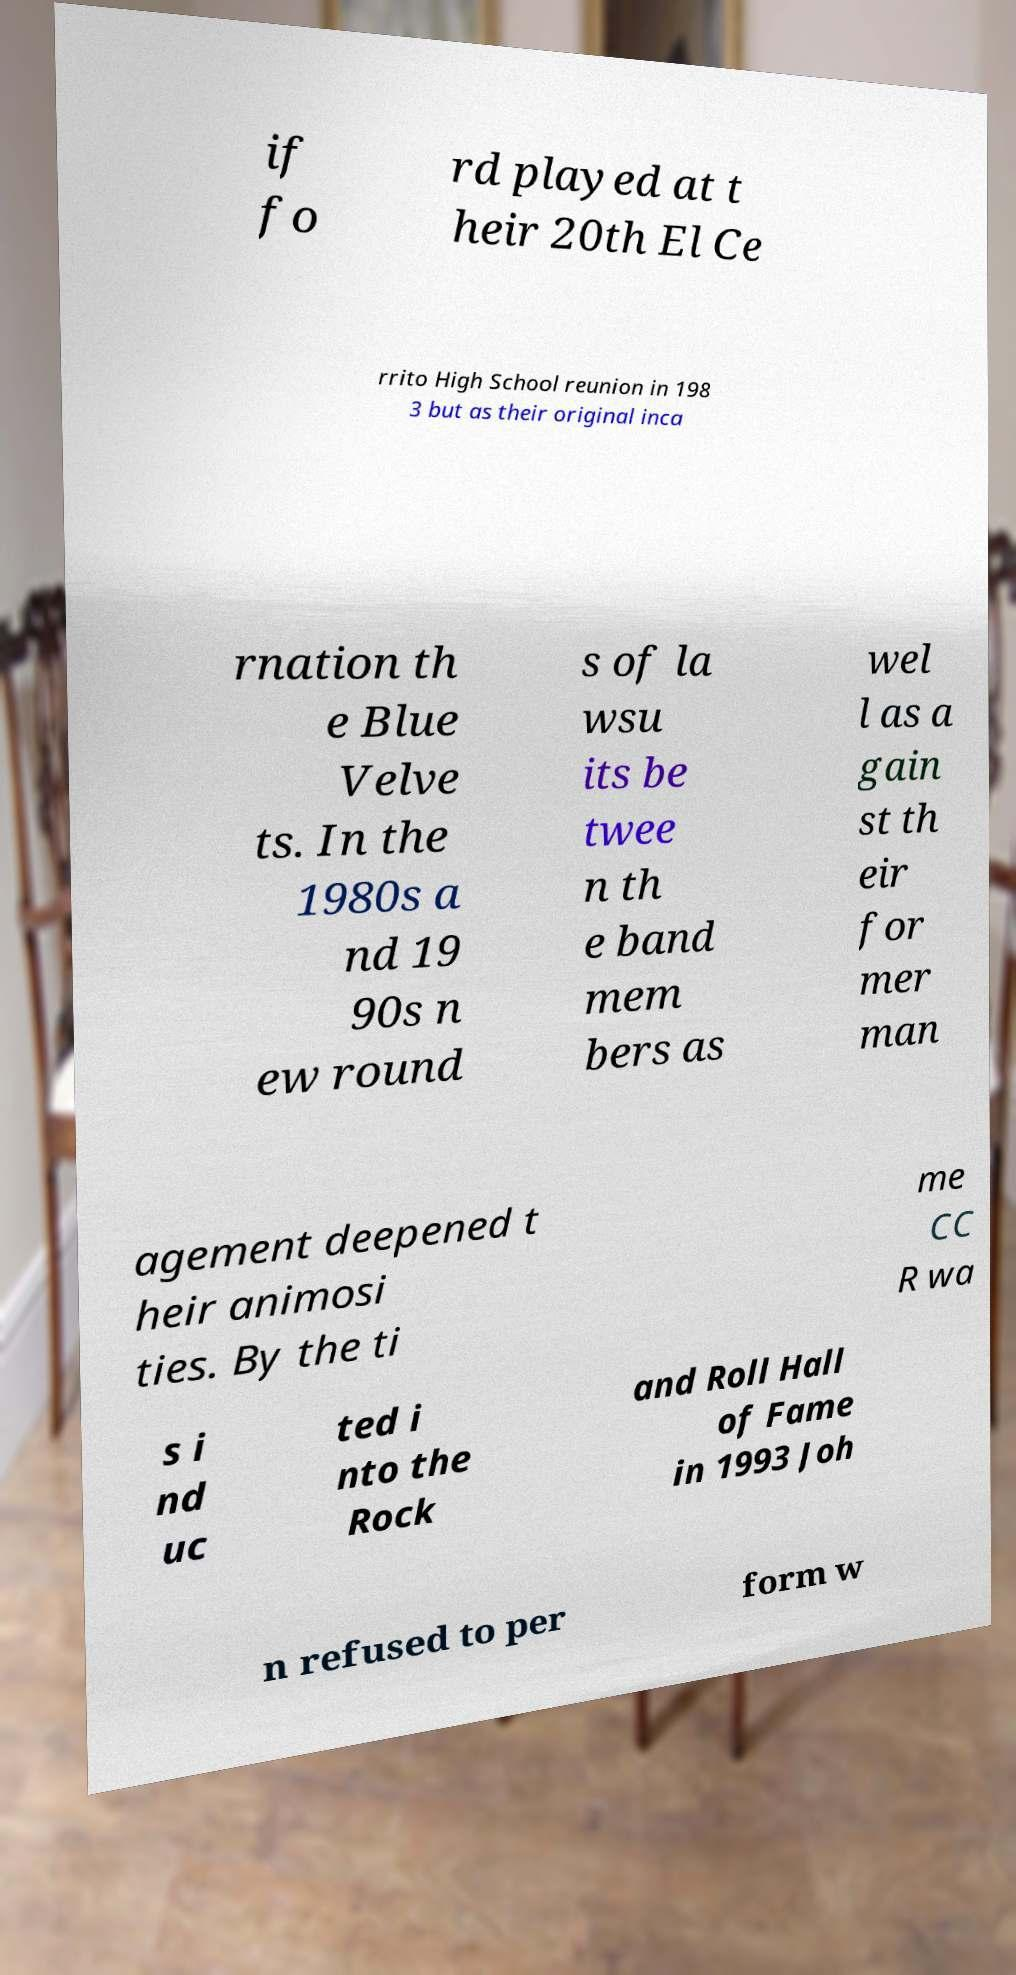Can you read and provide the text displayed in the image?This photo seems to have some interesting text. Can you extract and type it out for me? if fo rd played at t heir 20th El Ce rrito High School reunion in 198 3 but as their original inca rnation th e Blue Velve ts. In the 1980s a nd 19 90s n ew round s of la wsu its be twee n th e band mem bers as wel l as a gain st th eir for mer man agement deepened t heir animosi ties. By the ti me CC R wa s i nd uc ted i nto the Rock and Roll Hall of Fame in 1993 Joh n refused to per form w 